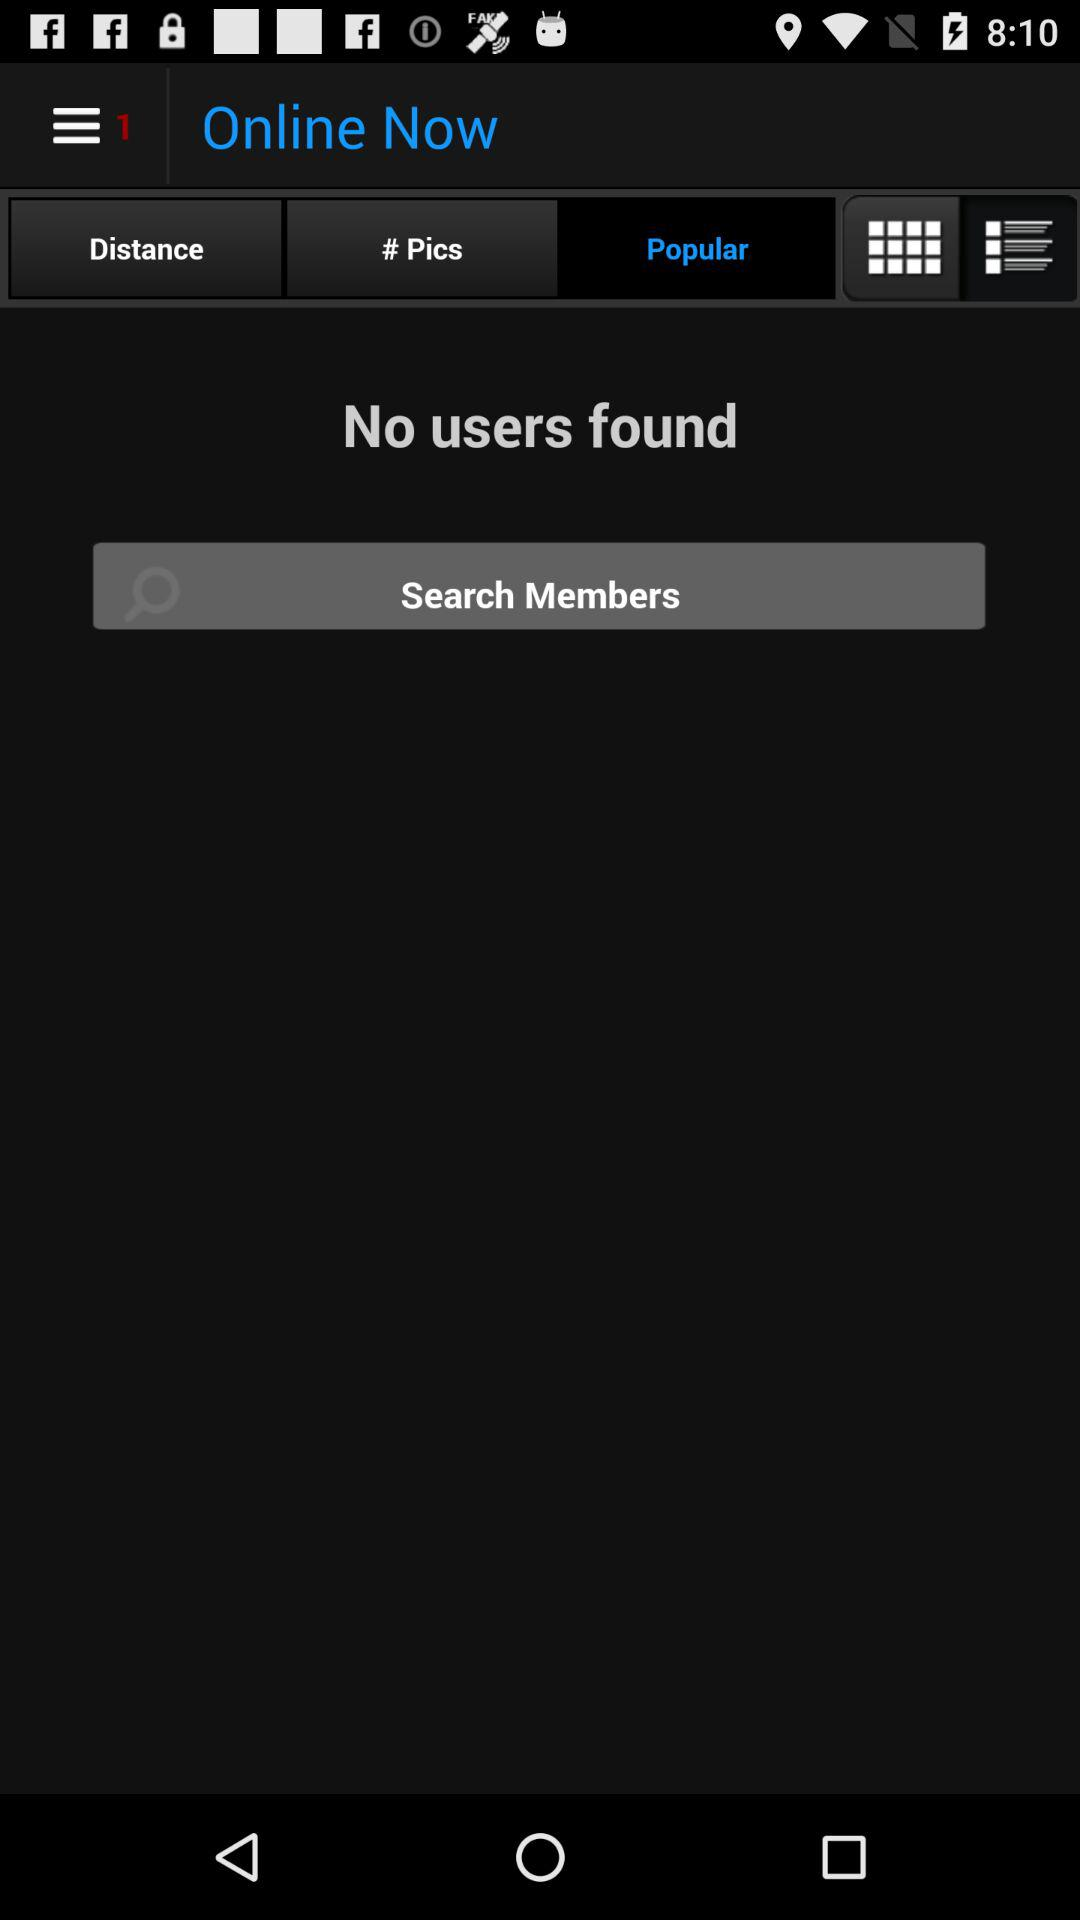How many users are found online? There are no online users. 